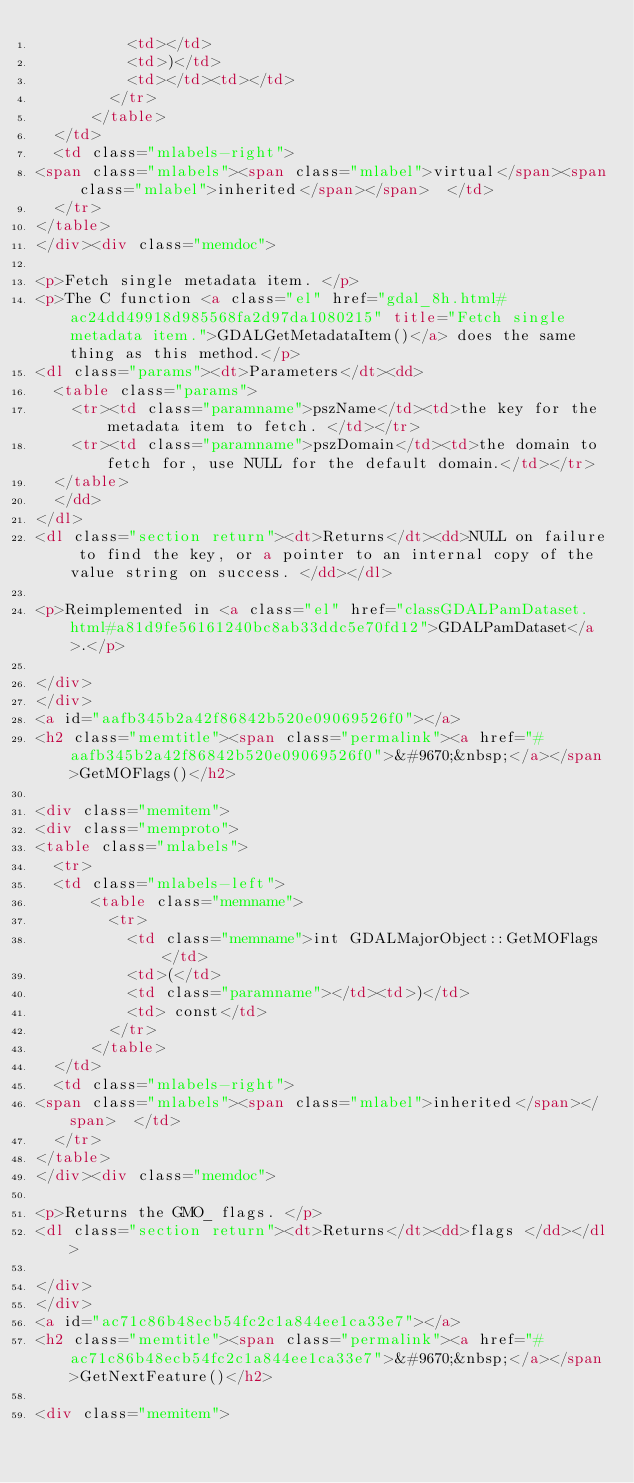Convert code to text. <code><loc_0><loc_0><loc_500><loc_500><_HTML_>          <td></td>
          <td>)</td>
          <td></td><td></td>
        </tr>
      </table>
  </td>
  <td class="mlabels-right">
<span class="mlabels"><span class="mlabel">virtual</span><span class="mlabel">inherited</span></span>  </td>
  </tr>
</table>
</div><div class="memdoc">

<p>Fetch single metadata item. </p>
<p>The C function <a class="el" href="gdal_8h.html#ac24dd49918d985568fa2d97da1080215" title="Fetch single metadata item.">GDALGetMetadataItem()</a> does the same thing as this method.</p>
<dl class="params"><dt>Parameters</dt><dd>
  <table class="params">
    <tr><td class="paramname">pszName</td><td>the key for the metadata item to fetch. </td></tr>
    <tr><td class="paramname">pszDomain</td><td>the domain to fetch for, use NULL for the default domain.</td></tr>
  </table>
  </dd>
</dl>
<dl class="section return"><dt>Returns</dt><dd>NULL on failure to find the key, or a pointer to an internal copy of the value string on success. </dd></dl>

<p>Reimplemented in <a class="el" href="classGDALPamDataset.html#a81d9fe56161240bc8ab33ddc5e70fd12">GDALPamDataset</a>.</p>

</div>
</div>
<a id="aafb345b2a42f86842b520e09069526f0"></a>
<h2 class="memtitle"><span class="permalink"><a href="#aafb345b2a42f86842b520e09069526f0">&#9670;&nbsp;</a></span>GetMOFlags()</h2>

<div class="memitem">
<div class="memproto">
<table class="mlabels">
  <tr>
  <td class="mlabels-left">
      <table class="memname">
        <tr>
          <td class="memname">int GDALMajorObject::GetMOFlags </td>
          <td>(</td>
          <td class="paramname"></td><td>)</td>
          <td> const</td>
        </tr>
      </table>
  </td>
  <td class="mlabels-right">
<span class="mlabels"><span class="mlabel">inherited</span></span>  </td>
  </tr>
</table>
</div><div class="memdoc">

<p>Returns the GMO_ flags. </p>
<dl class="section return"><dt>Returns</dt><dd>flags </dd></dl>

</div>
</div>
<a id="ac71c86b48ecb54fc2c1a844ee1ca33e7"></a>
<h2 class="memtitle"><span class="permalink"><a href="#ac71c86b48ecb54fc2c1a844ee1ca33e7">&#9670;&nbsp;</a></span>GetNextFeature()</h2>

<div class="memitem"></code> 